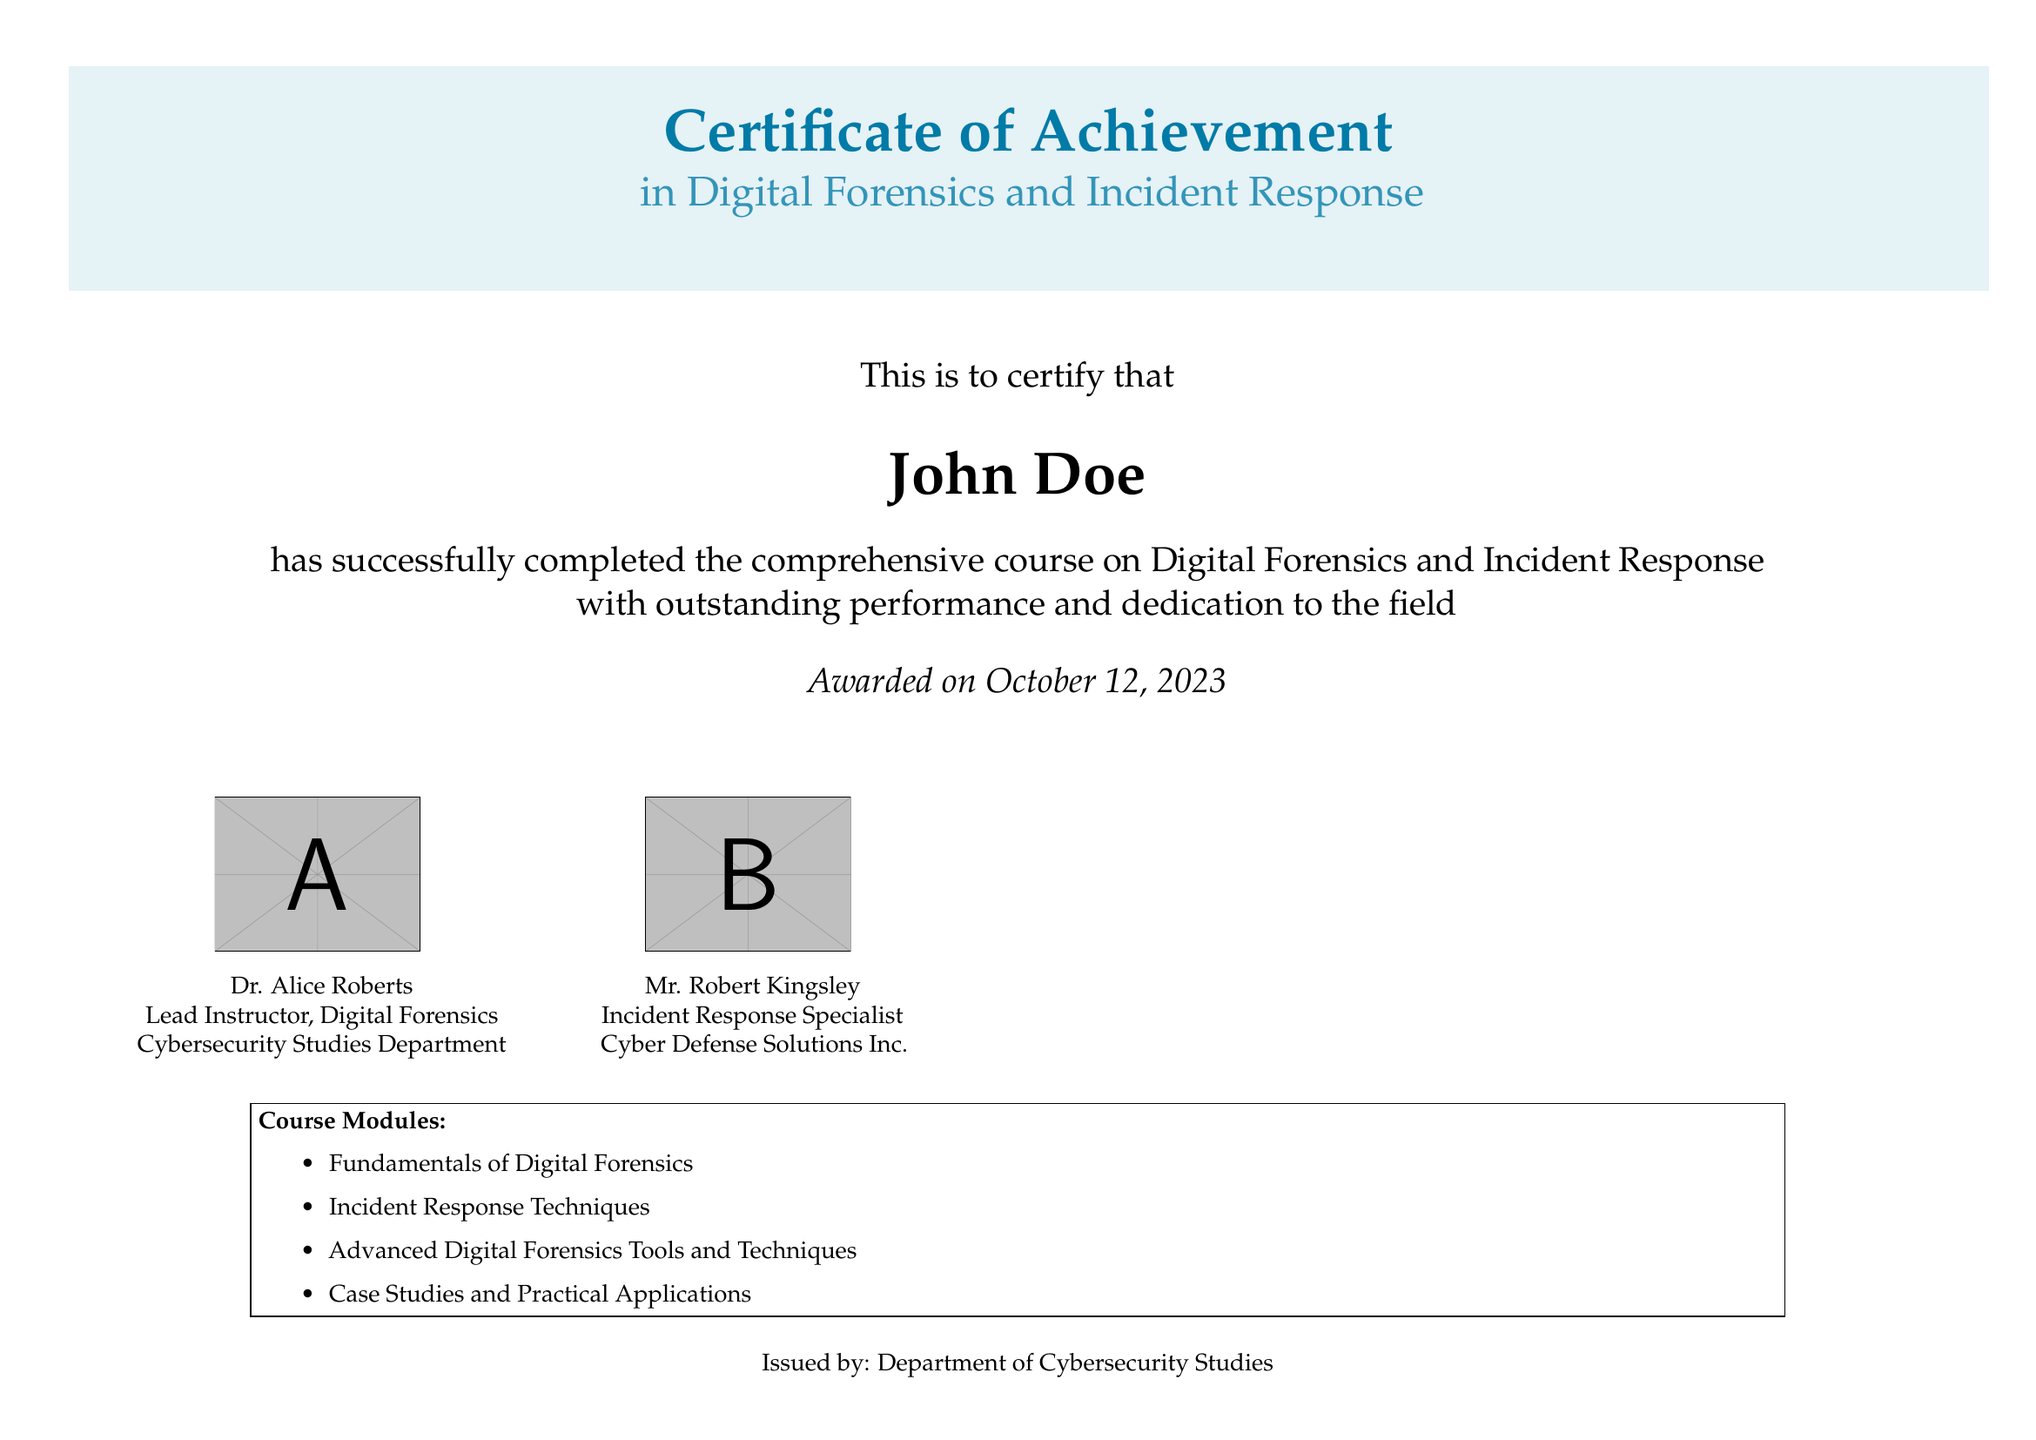What is the name of the recipient? The recipient's name is prominently displayed in the certificate right after the statement of achievement.
Answer: John Doe When was the certificate awarded? The award date is indicated at the bottom of the certificate, just above the issuer's information.
Answer: October 12, 2023 What course subject does this certificate represent? The subject of the course is clearly mentioned in the title of the certificate.
Answer: Digital Forensics and Incident Response Who is the lead instructor listed on the certificate? The name and title of the lead instructor are included below their signature on the certificate.
Answer: Dr. Alice Roberts What organization issued the certificate? The issuer's information is provided at the bottom of the document.
Answer: Department of Cybersecurity Studies How many course modules are listed? The document specifies the number of course modules included in the certificate information.
Answer: Four What type of certification is this document? The type of certification is stated clearly in the title, which is a common feature of such documents.
Answer: Certificate of Achievement Who is recognized as the Incident Response Specialist in this document? The specialist is named along with their title beneath their signature.
Answer: Mr. Robert Kingsley 